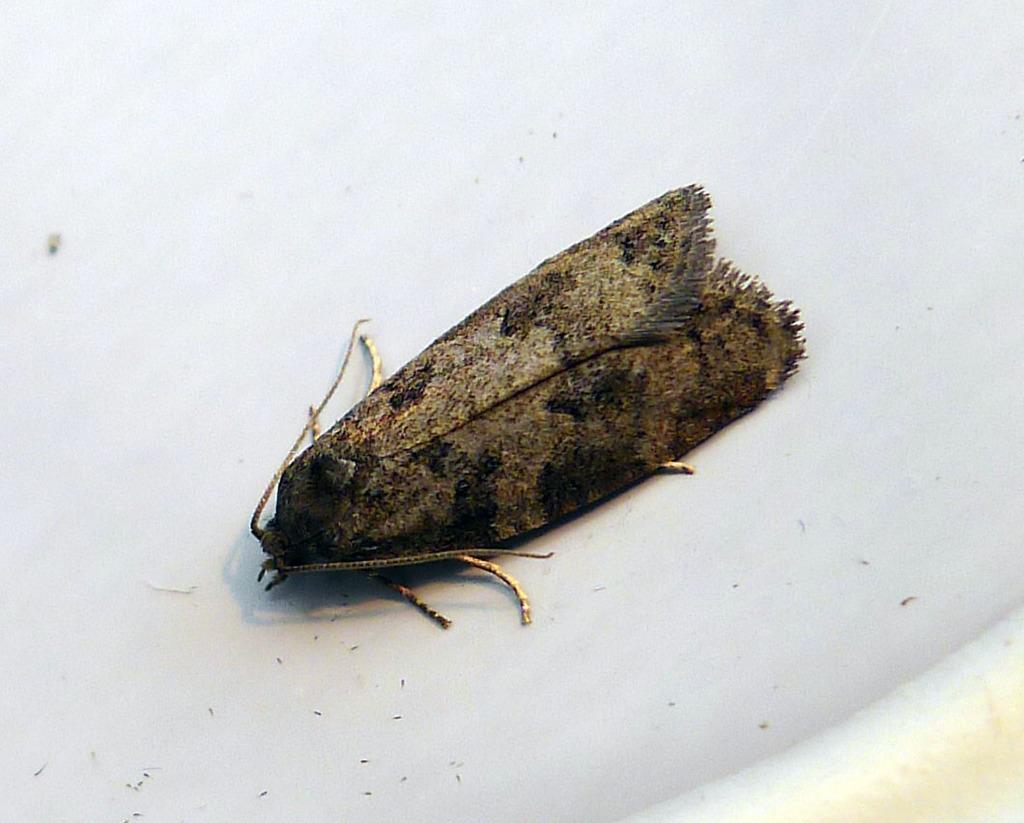Could you give a brief overview of what you see in this image? In this picture we can see an insect(Brown House Moth) on a white surface. 